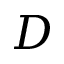<formula> <loc_0><loc_0><loc_500><loc_500>D</formula> 